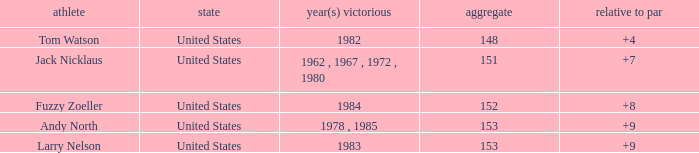What is the Total of the Player with a To par of 4? 1.0. 